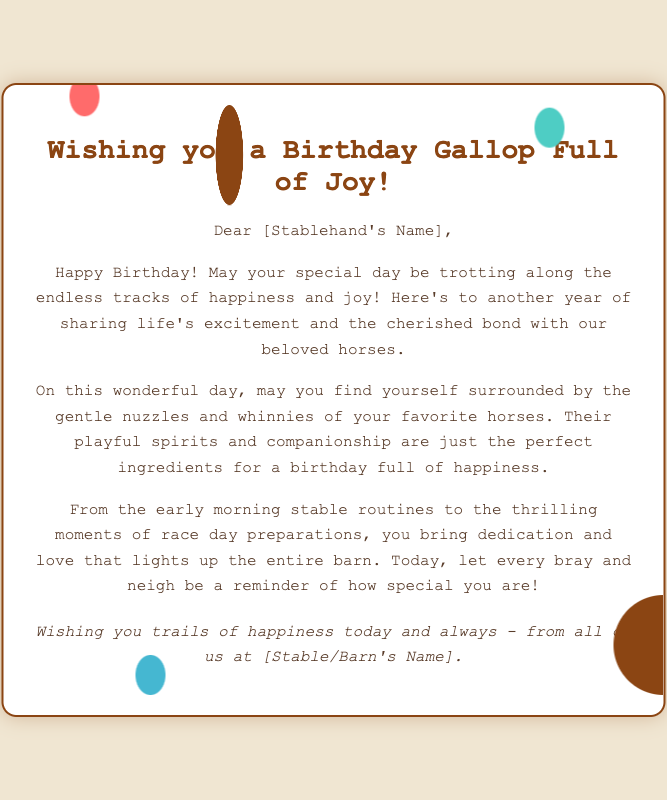What is the title of the card? The title is displayed prominently at the top of the card, wishing well to the stablehand.
Answer: Wishing you a Birthday Gallop Full of Joy! Who is the intended recipient of the card? The card is addressed directly to the stablehand, personalized by name.
Answer: [Stablehand's Name] What kind of animals are mentioned in the card? The card mentions specific types of animals that are significant to the stablehand's life and work.
Answer: Horses What does the card wish for the recipient's special day? The card expresses a specific hope for the recipient's experience on their birthday.
Answer: Happiness and joy What is emphasized about the stablehand's daily routine? The card highlights the stablehand's commitment to their work and the joy it brings.
Answer: Dedication and love How is the barn described in relation to the stablehand? The card conveys the influence the stablehand has on the barn atmosphere.
Answer: Lights up Which season is hinted at by the phrase “endless tracks”? The phrase evokes a certain imagery related to horse racing and training.
Answer: Racing What closing sentiment is expressed in the card? The card ends with a message reflecting ongoing good wishes for the recipient's future.
Answer: Trails of happiness today and always What colors are suggested by the card's design elements? The card’s design suggests warm and cheerful colors related to horse care.
Answer: Brown and pastels 